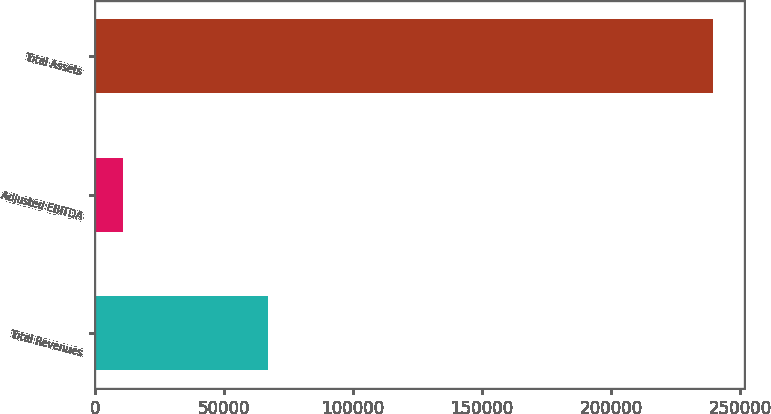Convert chart to OTSL. <chart><loc_0><loc_0><loc_500><loc_500><bar_chart><fcel>Total Revenues<fcel>Adjusted EBITDA<fcel>Total Assets<nl><fcel>67109<fcel>11066<fcel>239502<nl></chart> 